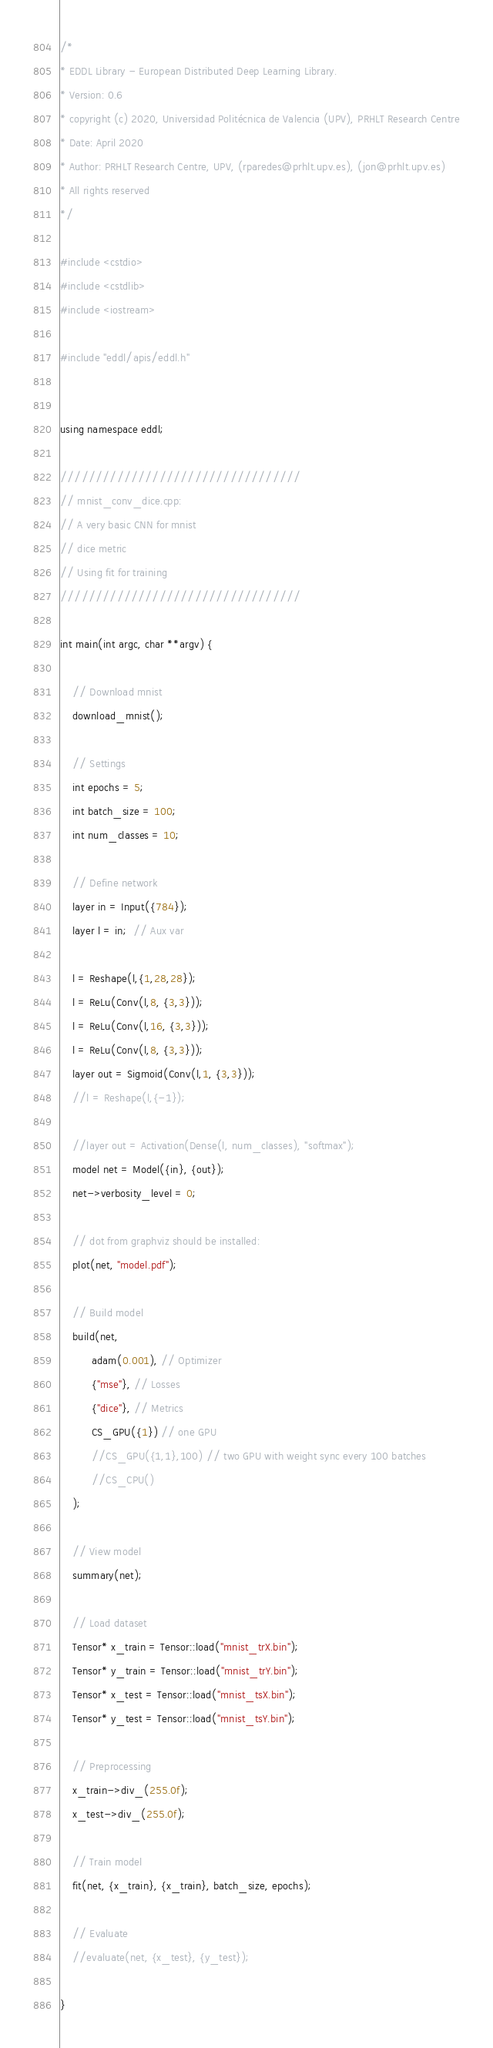<code> <loc_0><loc_0><loc_500><loc_500><_C++_>/*
* EDDL Library - European Distributed Deep Learning Library.
* Version: 0.6
* copyright (c) 2020, Universidad Politécnica de Valencia (UPV), PRHLT Research Centre
* Date: April 2020
* Author: PRHLT Research Centre, UPV, (rparedes@prhlt.upv.es), (jon@prhlt.upv.es)
* All rights reserved
*/

#include <cstdio>
#include <cstdlib>
#include <iostream>

#include "eddl/apis/eddl.h"


using namespace eddl;

//////////////////////////////////
// mnist_conv_dice.cpp:
// A very basic CNN for mnist
// dice metric
// Using fit for training
//////////////////////////////////

int main(int argc, char **argv) {

    // Download mnist
    download_mnist();

    // Settings
    int epochs = 5;
    int batch_size = 100;
    int num_classes = 10;

    // Define network
    layer in = Input({784});
    layer l = in;  // Aux var

    l = Reshape(l,{1,28,28});
    l = ReLu(Conv(l,8, {3,3}));
    l = ReLu(Conv(l,16, {3,3}));
    l = ReLu(Conv(l,8, {3,3}));
    layer out = Sigmoid(Conv(l,1, {3,3}));
    //l = Reshape(l,{-1});

    //layer out = Activation(Dense(l, num_classes), "softmax");
    model net = Model({in}, {out});
    net->verbosity_level = 0;

    // dot from graphviz should be installed:
    plot(net, "model.pdf");

    // Build model
    build(net,
          adam(0.001), // Optimizer
          {"mse"}, // Losses
          {"dice"}, // Metrics
          CS_GPU({1}) // one GPU
          //CS_GPU({1,1},100) // two GPU with weight sync every 100 batches
          //CS_CPU()
    );

    // View model
    summary(net);

    // Load dataset
    Tensor* x_train = Tensor::load("mnist_trX.bin");
    Tensor* y_train = Tensor::load("mnist_trY.bin");
    Tensor* x_test = Tensor::load("mnist_tsX.bin");
    Tensor* y_test = Tensor::load("mnist_tsY.bin");

    // Preprocessing
    x_train->div_(255.0f);
    x_test->div_(255.0f);

    // Train model
    fit(net, {x_train}, {x_train}, batch_size, epochs);

    // Evaluate
    //evaluate(net, {x_test}, {y_test});

}
</code> 